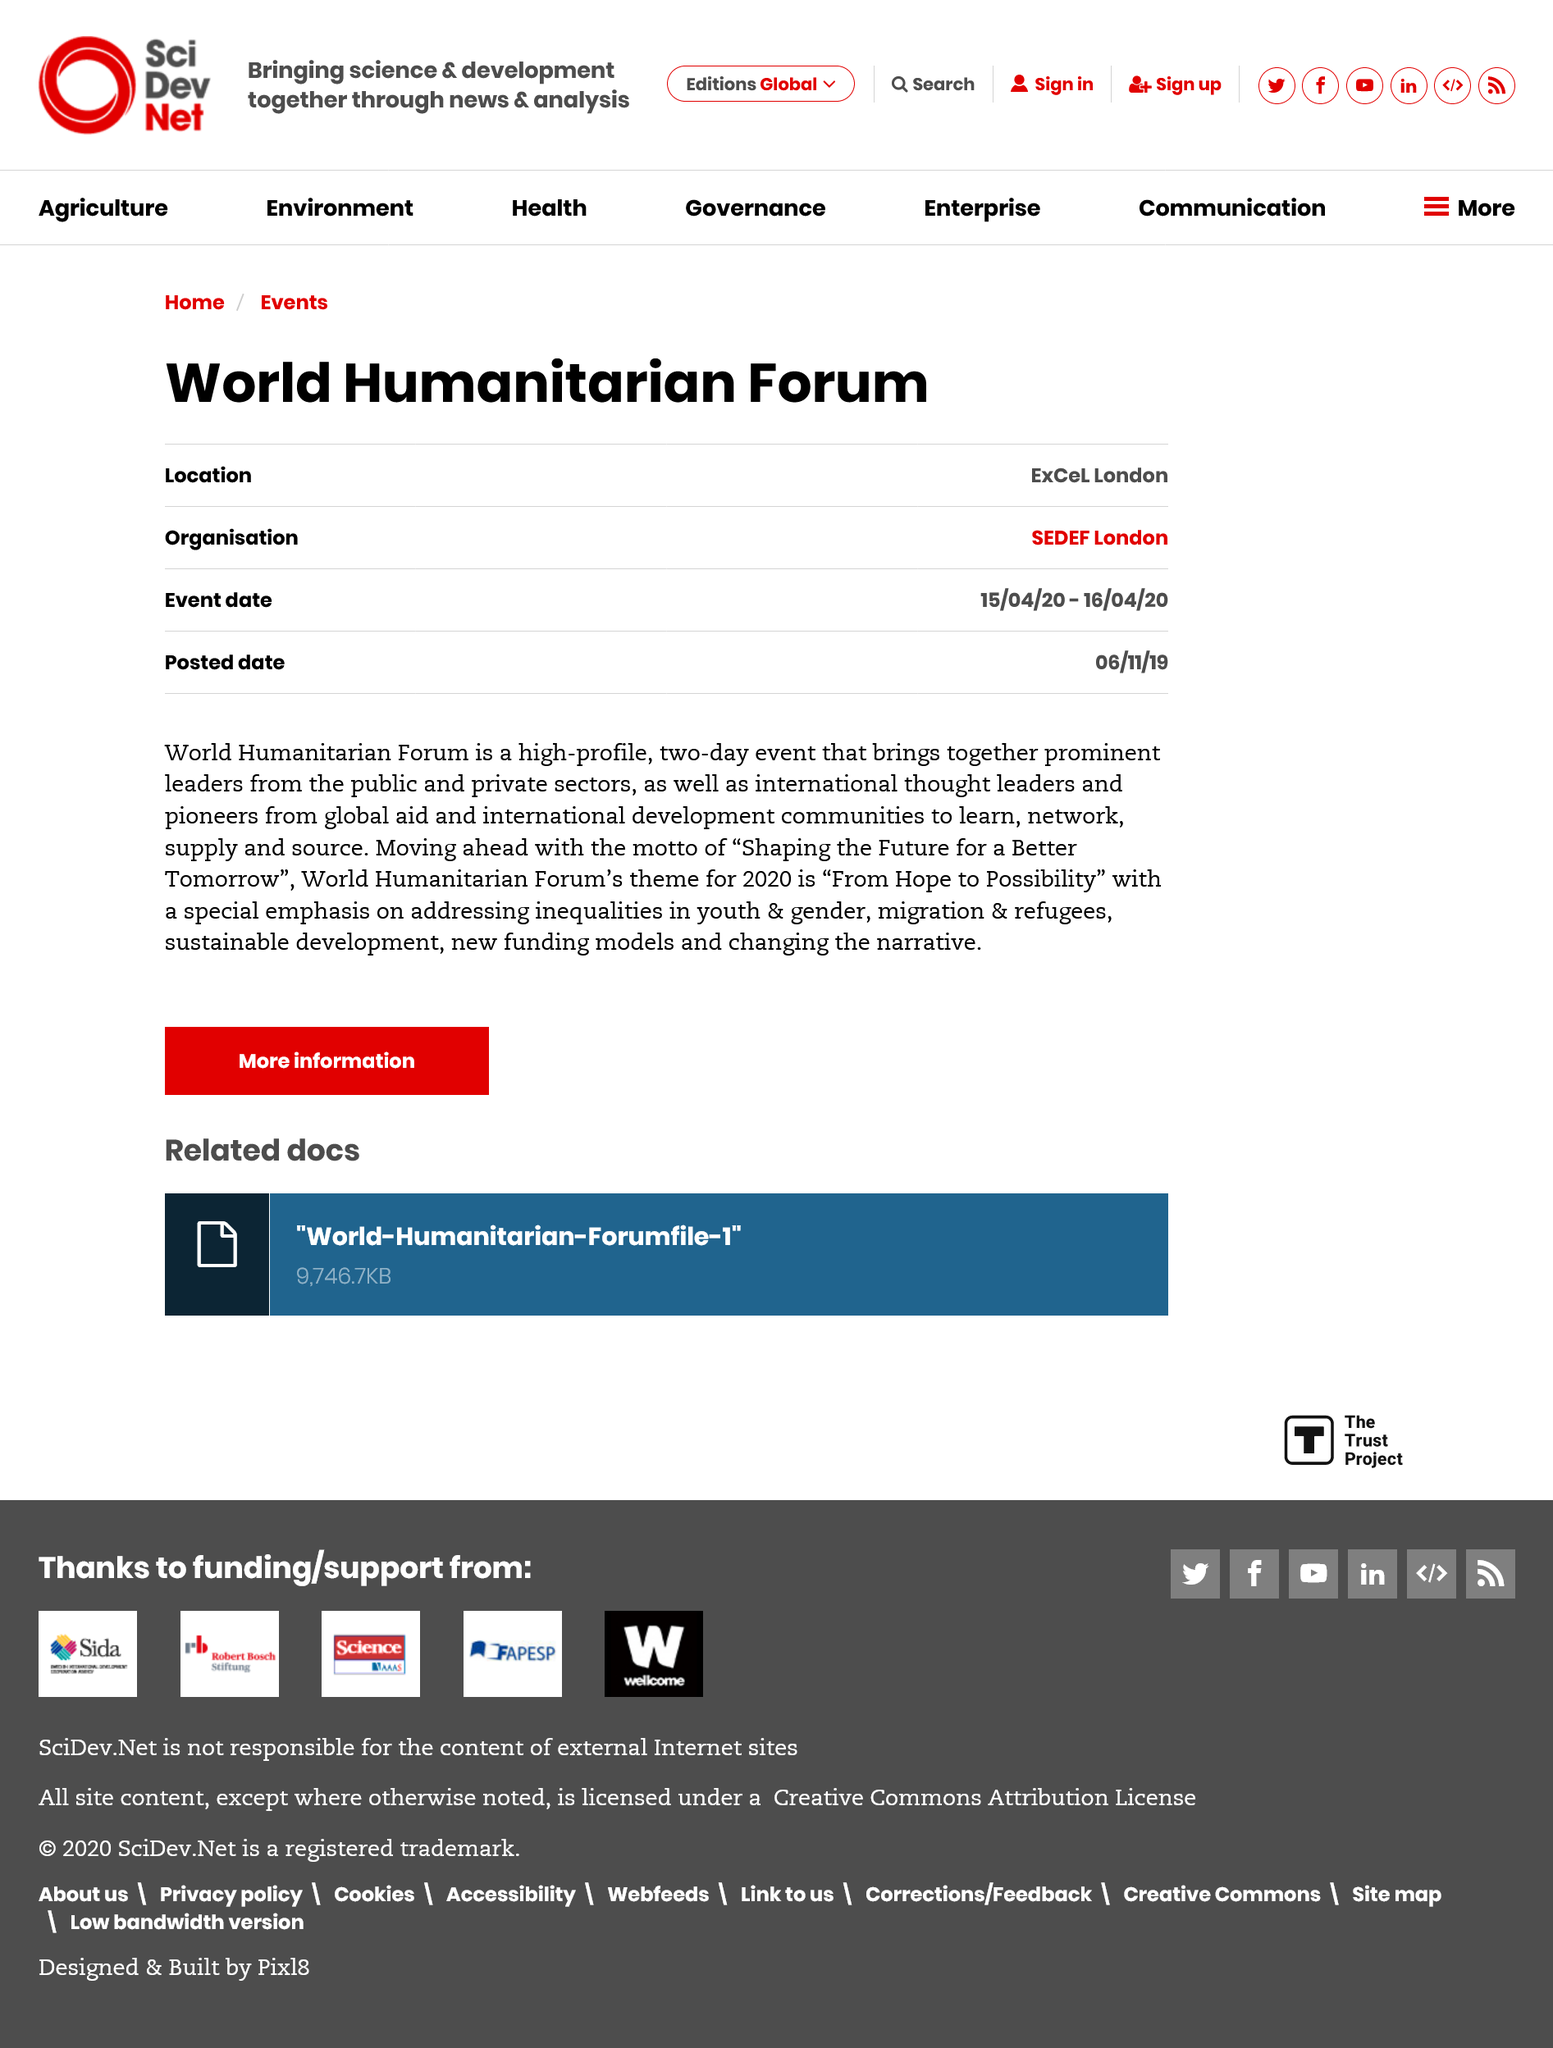Point out several critical features in this image. The World Humanitarian Forum event is expected to last for two days. The World Humanitarian Forum's theme for 2020 is "From Hope to Possibility" which emphasizes the transition from hope to concrete actions to improve humanitarian aid and assistance. The World Humanitarian Forum is to be held at the Excel in London on April 15th to April 20th, 2020. 